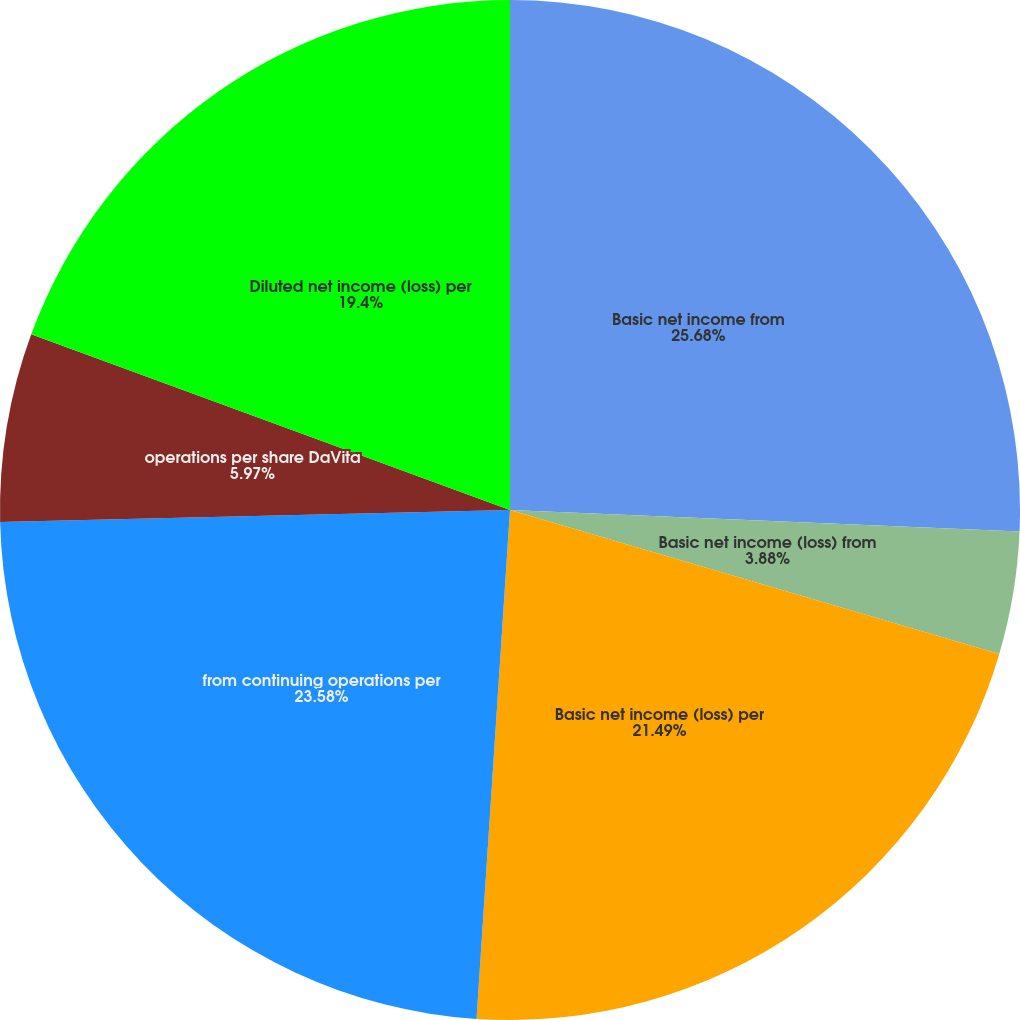<chart> <loc_0><loc_0><loc_500><loc_500><pie_chart><fcel>Basic net income from<fcel>Basic net income (loss) from<fcel>Basic net income (loss) per<fcel>from continuing operations per<fcel>operations per share DaVita<fcel>Diluted net income (loss) per<nl><fcel>25.67%<fcel>3.88%<fcel>21.49%<fcel>23.58%<fcel>5.97%<fcel>19.4%<nl></chart> 